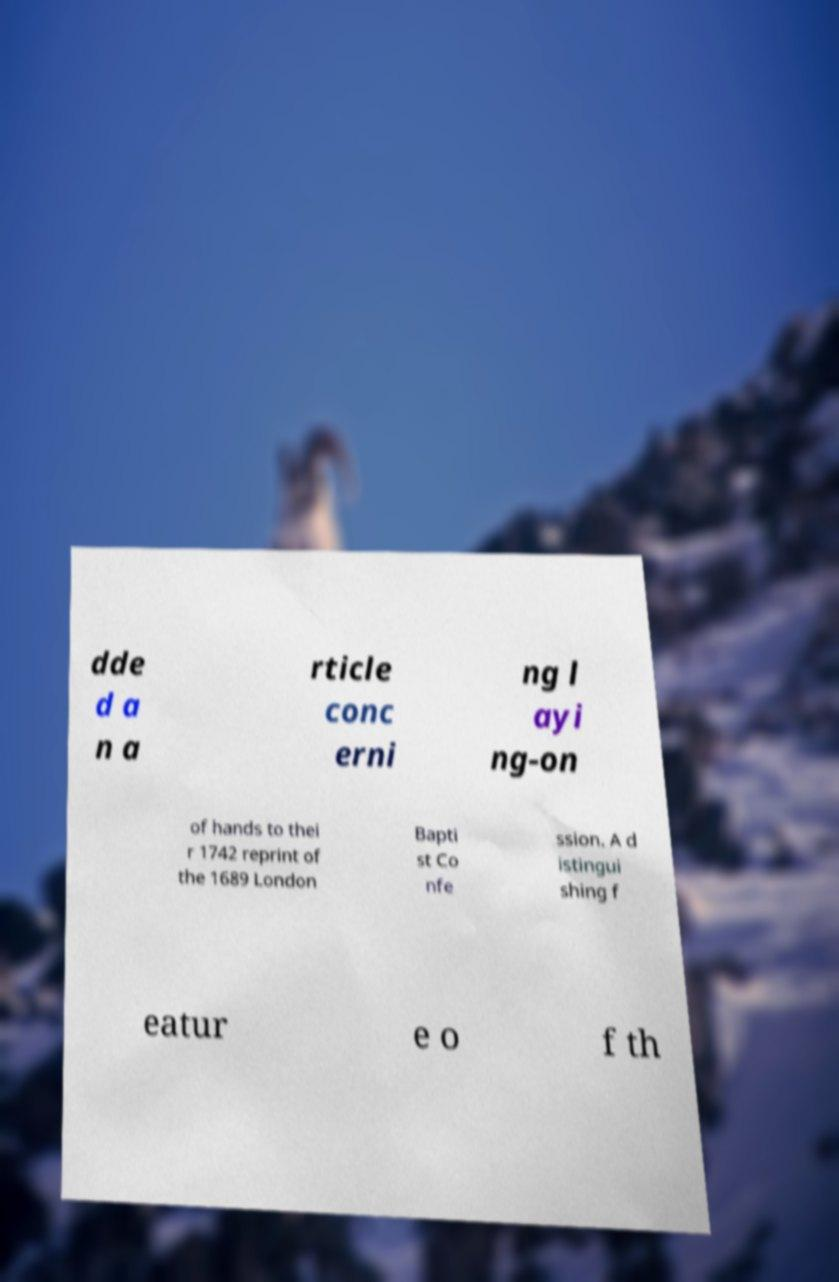For documentation purposes, I need the text within this image transcribed. Could you provide that? dde d a n a rticle conc erni ng l ayi ng-on of hands to thei r 1742 reprint of the 1689 London Bapti st Co nfe ssion. A d istingui shing f eatur e o f th 